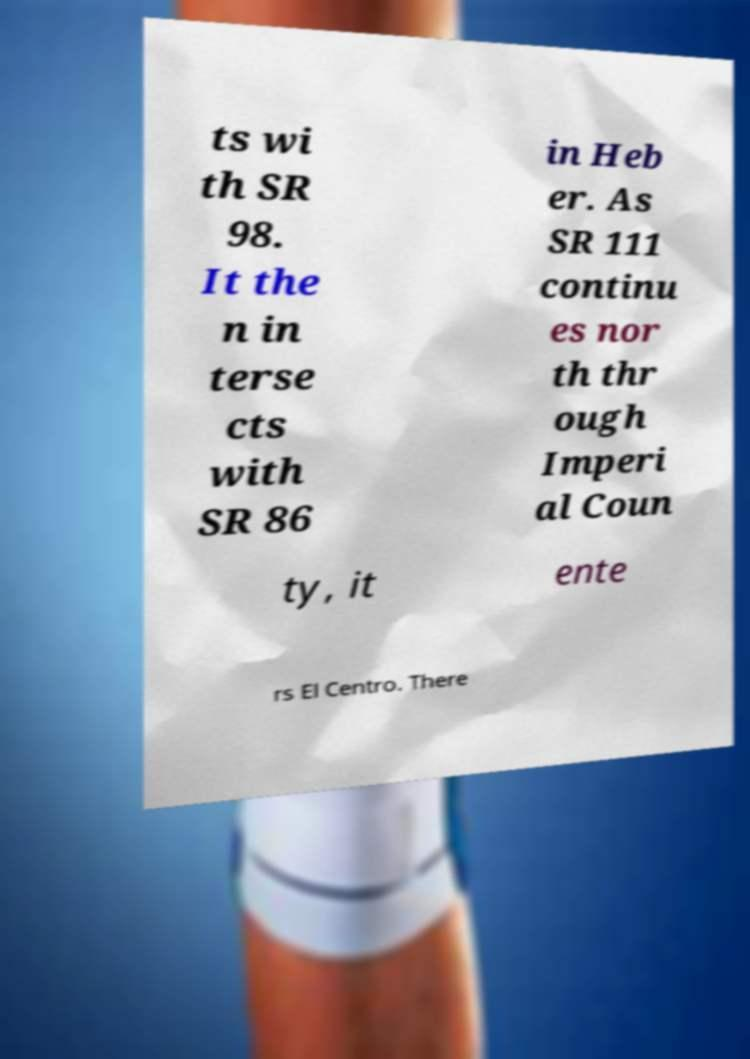Could you extract and type out the text from this image? ts wi th SR 98. It the n in terse cts with SR 86 in Heb er. As SR 111 continu es nor th thr ough Imperi al Coun ty, it ente rs El Centro. There 